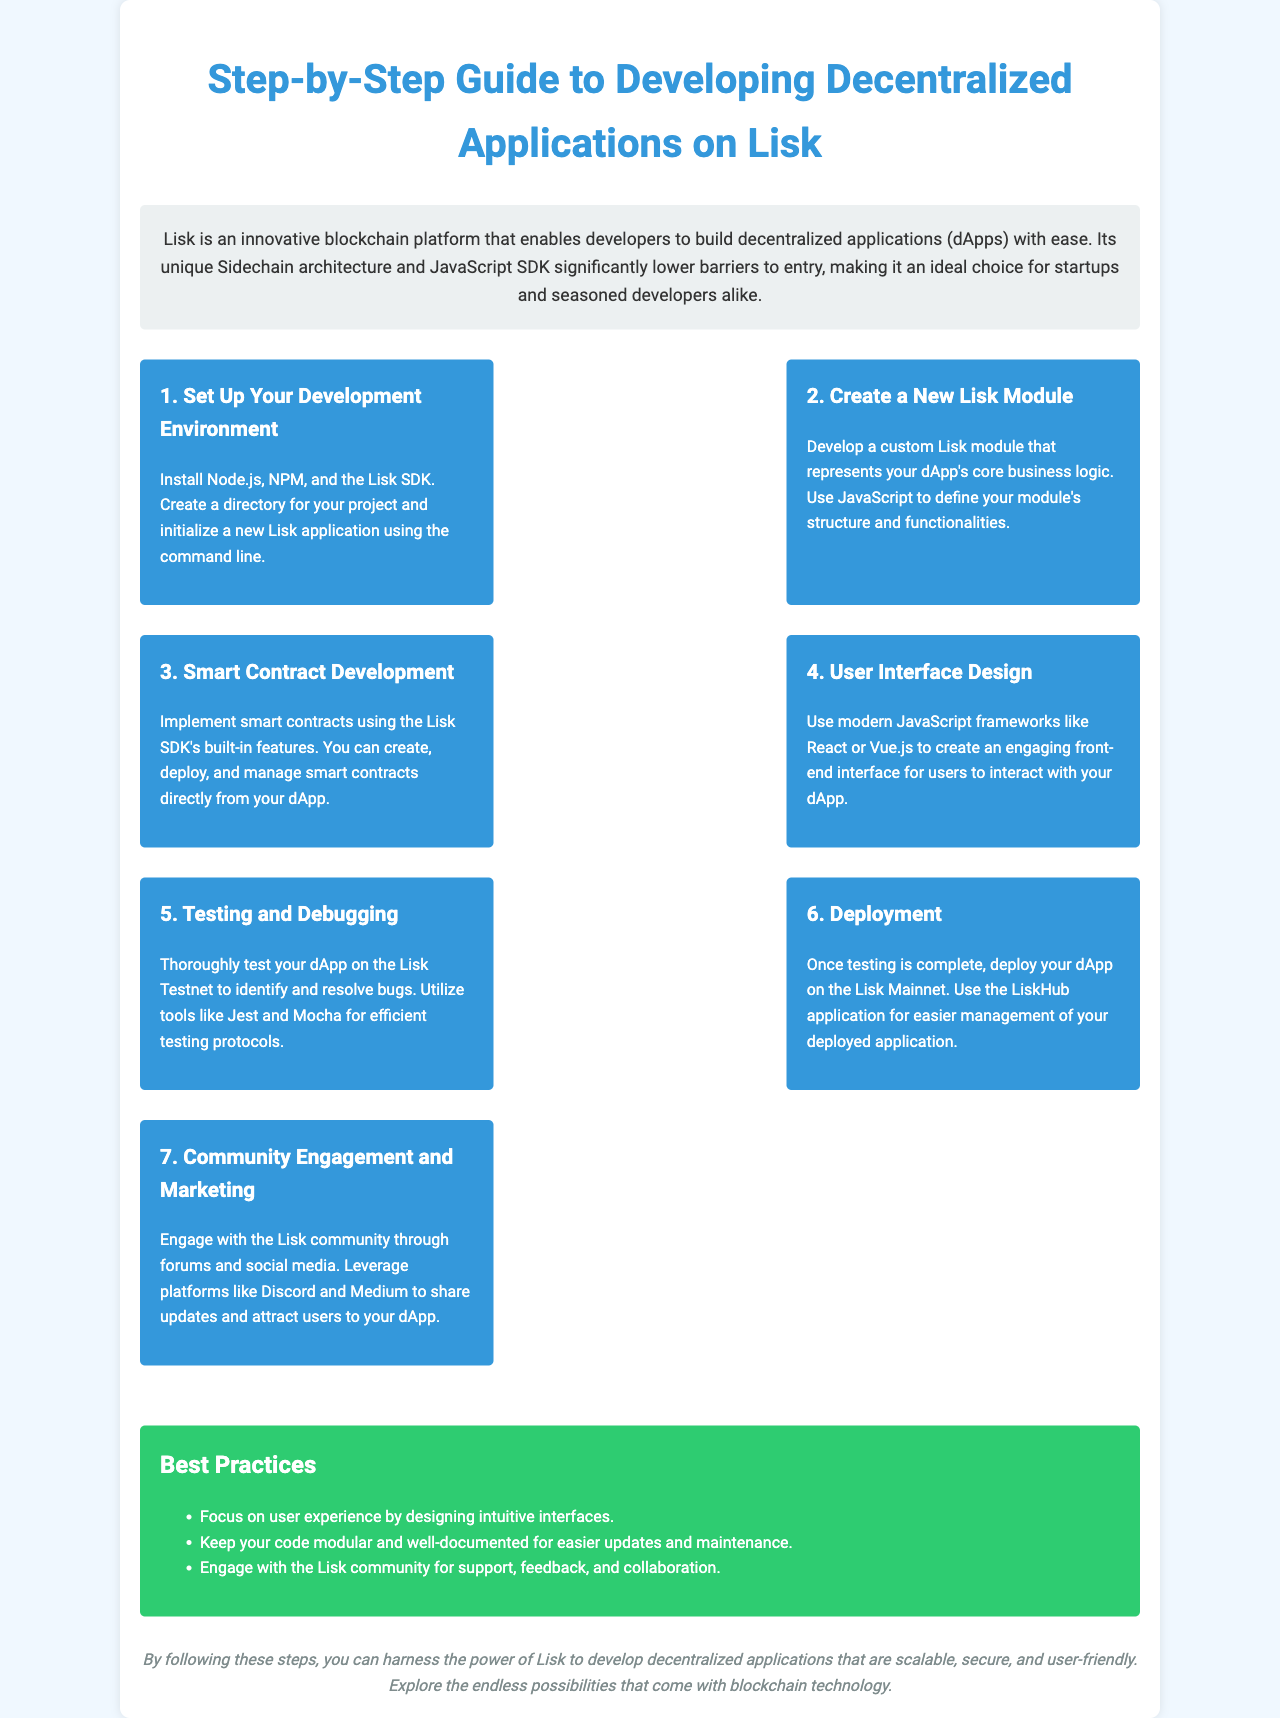what is the title of the document? The title is stated at the top of the document, which introduces the main subject covered, focusing on developing decentralized applications on Lisk.
Answer: Step-by-Step Guide to Developing Decentralized Applications on Lisk how many steps are outlined in the guide? The guide lists the number of steps required to develop decentralized applications on Lisk, which can be counted from the list of steps.
Answer: 7 what framework is suggested for UI design? The document mentions modern frameworks for user interface design with specific examples in the UI design section.
Answer: React or Vue.js what is the main purpose of Lisk mentioned in the introduction? The introduction summarizes the main functionality of Lisk, specifically its goal related to application development, indicating its ease of use for developers.
Answer: Build decentralized applications name one tool recommended for testing. The document includes a section on testing and debugging, where specific tools are listed for testing protocols in the application development process.
Answer: Jest what should developers focus on in user experience? The best practices section emphasizes important aspects that developers should consider to enhance user experience in their applications.
Answer: Designing intuitive interfaces which community platforms are suggested for engagement? In the community engagement section, several platforms are identified where developers can connect and share updates about their dApps.
Answer: Discord and Medium what color is used for the best practices section? The document uses specific colors for different sections, and the color associated with the best practices section is specified in the visual design.
Answer: Green 